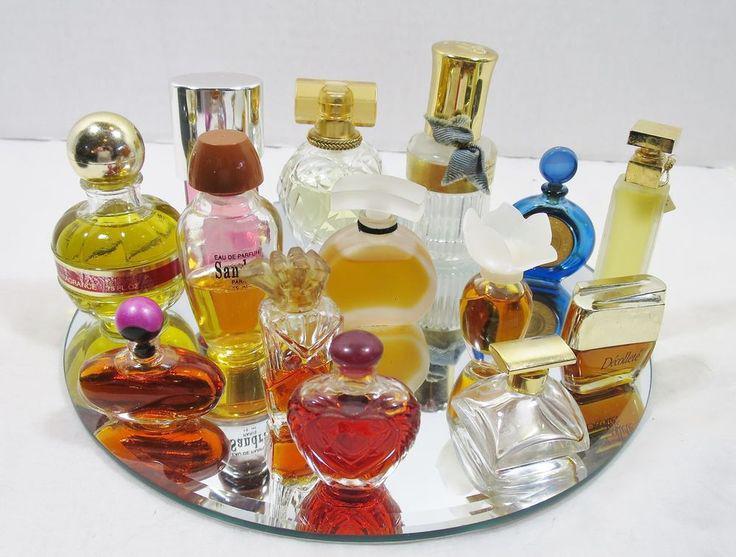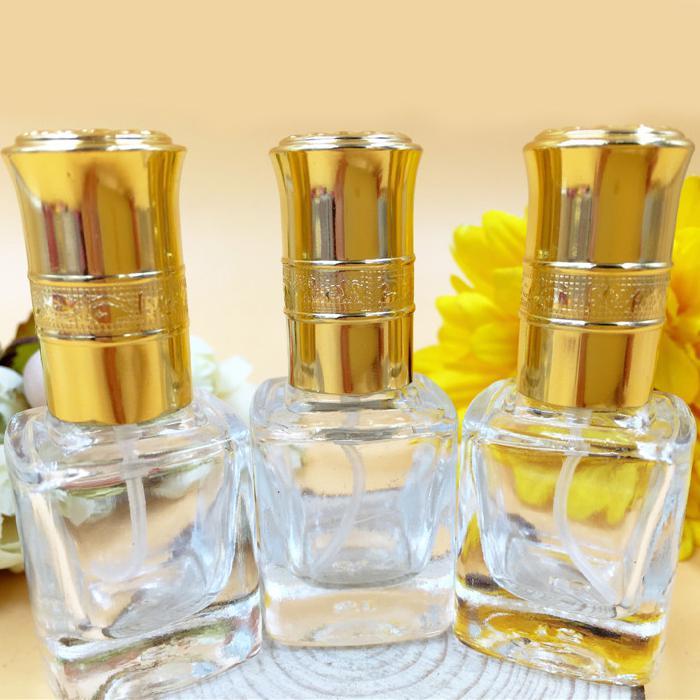The first image is the image on the left, the second image is the image on the right. Given the left and right images, does the statement "One image includes a row of at least three clear glass fragrance bottles with tall metallic caps, and the other image includes several roundish bottles with round caps." hold true? Answer yes or no. Yes. The first image is the image on the left, the second image is the image on the right. Considering the images on both sides, is "All products are standing upright." valid? Answer yes or no. Yes. 